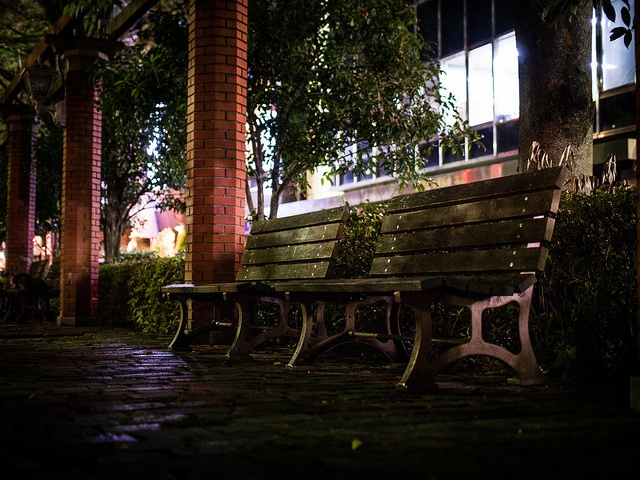Describe the objects in this image and their specific colors. I can see bench in black, maroon, olive, and gray tones and bench in black and olive tones in this image. 